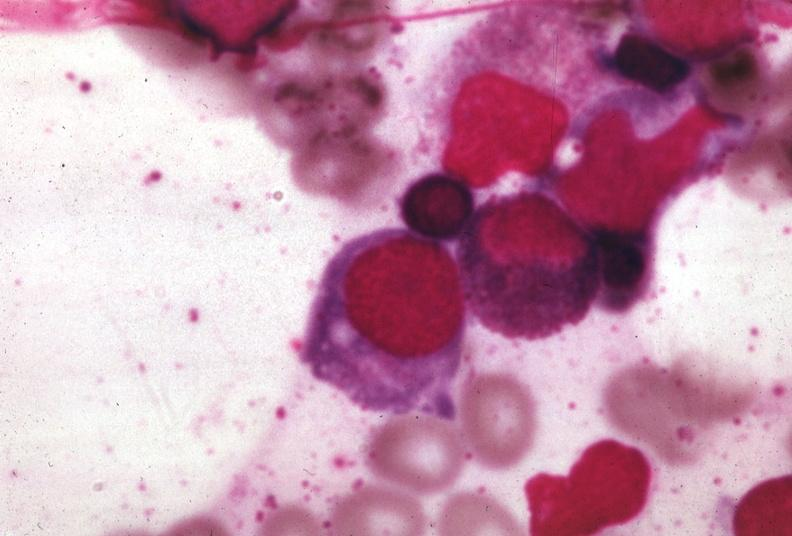s peritoneal surface of uterus and douglas pouch outstanding photo primary present?
Answer the question using a single word or phrase. No 